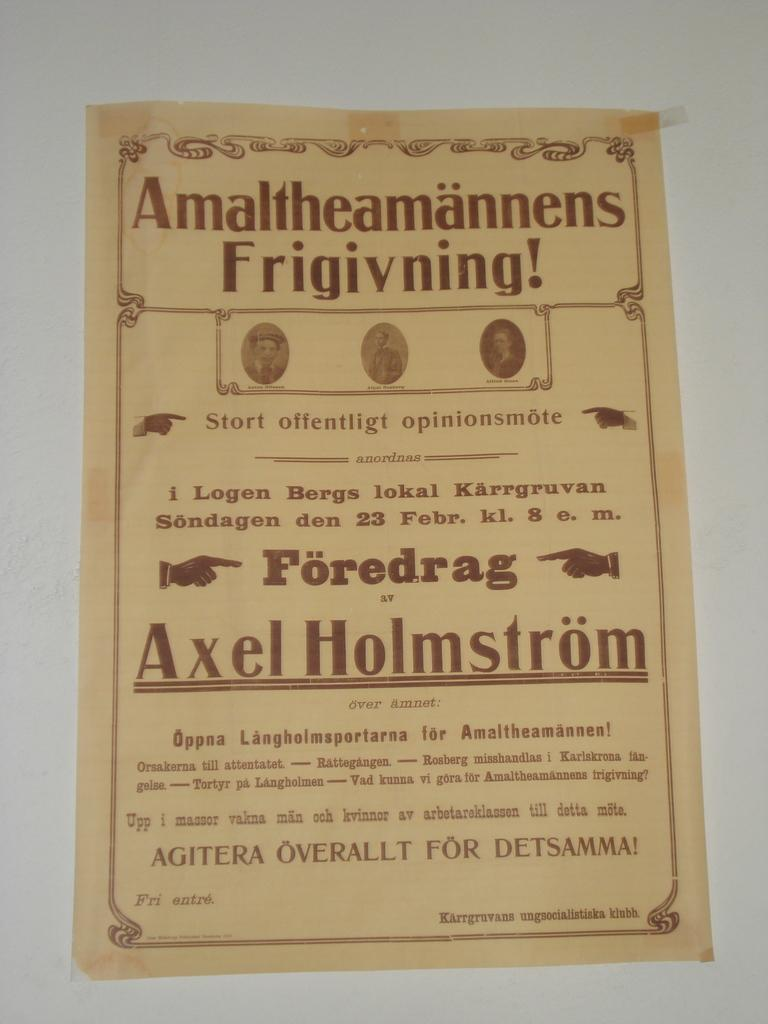<image>
Present a compact description of the photo's key features. A flyer not in English that features Axel Holmstrom. 